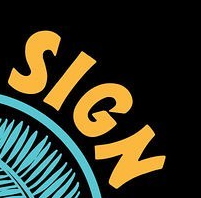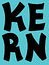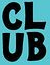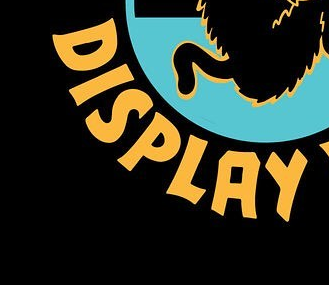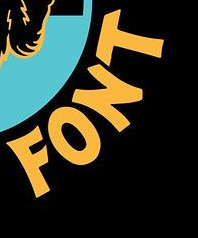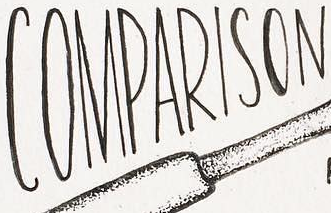Transcribe the words shown in these images in order, separated by a semicolon. SIGN; KERN; CLUB; DISPLAY; FONT; COMPARISON 